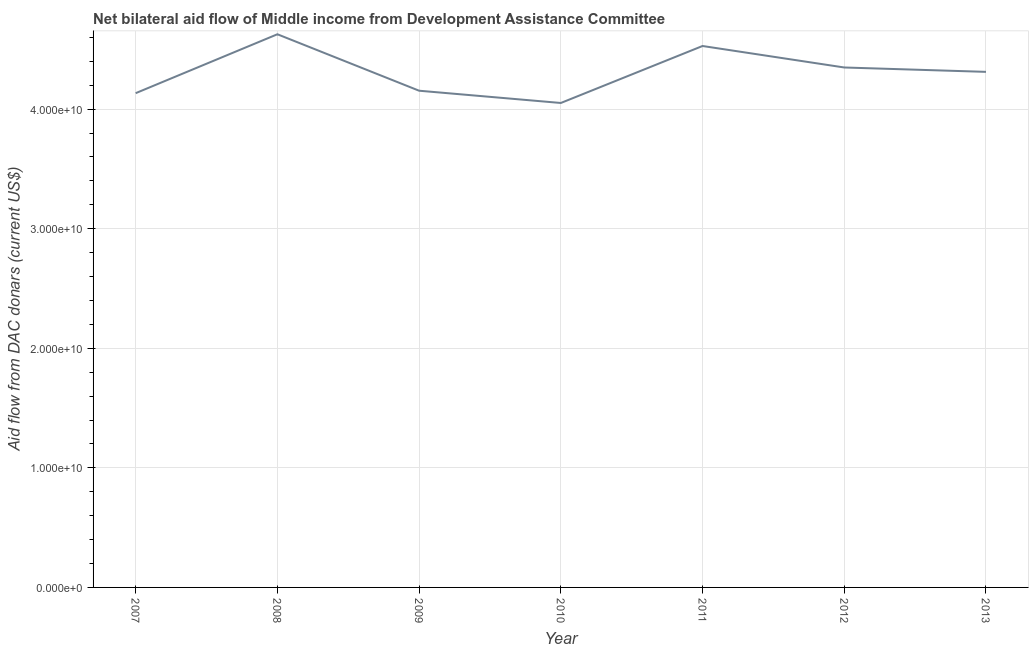What is the net bilateral aid flows from dac donors in 2010?
Your answer should be very brief. 4.05e+1. Across all years, what is the maximum net bilateral aid flows from dac donors?
Make the answer very short. 4.63e+1. Across all years, what is the minimum net bilateral aid flows from dac donors?
Provide a short and direct response. 4.05e+1. In which year was the net bilateral aid flows from dac donors minimum?
Offer a very short reply. 2010. What is the sum of the net bilateral aid flows from dac donors?
Provide a short and direct response. 3.02e+11. What is the difference between the net bilateral aid flows from dac donors in 2007 and 2011?
Keep it short and to the point. -3.94e+09. What is the average net bilateral aid flows from dac donors per year?
Ensure brevity in your answer.  4.31e+1. What is the median net bilateral aid flows from dac donors?
Your answer should be compact. 4.31e+1. In how many years, is the net bilateral aid flows from dac donors greater than 26000000000 US$?
Your answer should be compact. 7. Do a majority of the years between 2013 and 2008 (inclusive) have net bilateral aid flows from dac donors greater than 40000000000 US$?
Give a very brief answer. Yes. What is the ratio of the net bilateral aid flows from dac donors in 2009 to that in 2013?
Provide a succinct answer. 0.96. Is the net bilateral aid flows from dac donors in 2007 less than that in 2009?
Provide a short and direct response. Yes. Is the difference between the net bilateral aid flows from dac donors in 2007 and 2012 greater than the difference between any two years?
Your response must be concise. No. What is the difference between the highest and the second highest net bilateral aid flows from dac donors?
Your answer should be very brief. 9.81e+08. Is the sum of the net bilateral aid flows from dac donors in 2009 and 2010 greater than the maximum net bilateral aid flows from dac donors across all years?
Your answer should be very brief. Yes. What is the difference between the highest and the lowest net bilateral aid flows from dac donors?
Offer a very short reply. 5.75e+09. In how many years, is the net bilateral aid flows from dac donors greater than the average net bilateral aid flows from dac donors taken over all years?
Make the answer very short. 4. Does the net bilateral aid flows from dac donors monotonically increase over the years?
Ensure brevity in your answer.  No. How many years are there in the graph?
Provide a short and direct response. 7. Are the values on the major ticks of Y-axis written in scientific E-notation?
Your answer should be compact. Yes. What is the title of the graph?
Provide a short and direct response. Net bilateral aid flow of Middle income from Development Assistance Committee. What is the label or title of the X-axis?
Provide a short and direct response. Year. What is the label or title of the Y-axis?
Give a very brief answer. Aid flow from DAC donars (current US$). What is the Aid flow from DAC donars (current US$) in 2007?
Your answer should be very brief. 4.13e+1. What is the Aid flow from DAC donars (current US$) of 2008?
Provide a succinct answer. 4.63e+1. What is the Aid flow from DAC donars (current US$) of 2009?
Offer a terse response. 4.15e+1. What is the Aid flow from DAC donars (current US$) of 2010?
Your answer should be very brief. 4.05e+1. What is the Aid flow from DAC donars (current US$) of 2011?
Provide a short and direct response. 4.53e+1. What is the Aid flow from DAC donars (current US$) of 2012?
Keep it short and to the point. 4.35e+1. What is the Aid flow from DAC donars (current US$) of 2013?
Offer a terse response. 4.31e+1. What is the difference between the Aid flow from DAC donars (current US$) in 2007 and 2008?
Keep it short and to the point. -4.93e+09. What is the difference between the Aid flow from DAC donars (current US$) in 2007 and 2009?
Offer a very short reply. -2.05e+08. What is the difference between the Aid flow from DAC donars (current US$) in 2007 and 2010?
Ensure brevity in your answer.  8.20e+08. What is the difference between the Aid flow from DAC donars (current US$) in 2007 and 2011?
Your answer should be compact. -3.94e+09. What is the difference between the Aid flow from DAC donars (current US$) in 2007 and 2012?
Offer a terse response. -2.15e+09. What is the difference between the Aid flow from DAC donars (current US$) in 2007 and 2013?
Offer a terse response. -1.78e+09. What is the difference between the Aid flow from DAC donars (current US$) in 2008 and 2009?
Your response must be concise. 4.72e+09. What is the difference between the Aid flow from DAC donars (current US$) in 2008 and 2010?
Your answer should be compact. 5.75e+09. What is the difference between the Aid flow from DAC donars (current US$) in 2008 and 2011?
Offer a very short reply. 9.81e+08. What is the difference between the Aid flow from DAC donars (current US$) in 2008 and 2012?
Your answer should be compact. 2.78e+09. What is the difference between the Aid flow from DAC donars (current US$) in 2008 and 2013?
Make the answer very short. 3.14e+09. What is the difference between the Aid flow from DAC donars (current US$) in 2009 and 2010?
Provide a short and direct response. 1.03e+09. What is the difference between the Aid flow from DAC donars (current US$) in 2009 and 2011?
Your answer should be very brief. -3.74e+09. What is the difference between the Aid flow from DAC donars (current US$) in 2009 and 2012?
Your answer should be very brief. -1.94e+09. What is the difference between the Aid flow from DAC donars (current US$) in 2009 and 2013?
Your answer should be compact. -1.58e+09. What is the difference between the Aid flow from DAC donars (current US$) in 2010 and 2011?
Your answer should be very brief. -4.76e+09. What is the difference between the Aid flow from DAC donars (current US$) in 2010 and 2012?
Your response must be concise. -2.97e+09. What is the difference between the Aid flow from DAC donars (current US$) in 2010 and 2013?
Your response must be concise. -2.60e+09. What is the difference between the Aid flow from DAC donars (current US$) in 2011 and 2012?
Your response must be concise. 1.80e+09. What is the difference between the Aid flow from DAC donars (current US$) in 2011 and 2013?
Offer a very short reply. 2.16e+09. What is the difference between the Aid flow from DAC donars (current US$) in 2012 and 2013?
Provide a short and direct response. 3.66e+08. What is the ratio of the Aid flow from DAC donars (current US$) in 2007 to that in 2008?
Provide a short and direct response. 0.89. What is the ratio of the Aid flow from DAC donars (current US$) in 2007 to that in 2009?
Your answer should be compact. 0.99. What is the ratio of the Aid flow from DAC donars (current US$) in 2007 to that in 2011?
Give a very brief answer. 0.91. What is the ratio of the Aid flow from DAC donars (current US$) in 2007 to that in 2012?
Your answer should be compact. 0.95. What is the ratio of the Aid flow from DAC donars (current US$) in 2007 to that in 2013?
Give a very brief answer. 0.96. What is the ratio of the Aid flow from DAC donars (current US$) in 2008 to that in 2009?
Keep it short and to the point. 1.11. What is the ratio of the Aid flow from DAC donars (current US$) in 2008 to that in 2010?
Make the answer very short. 1.14. What is the ratio of the Aid flow from DAC donars (current US$) in 2008 to that in 2011?
Offer a terse response. 1.02. What is the ratio of the Aid flow from DAC donars (current US$) in 2008 to that in 2012?
Provide a short and direct response. 1.06. What is the ratio of the Aid flow from DAC donars (current US$) in 2008 to that in 2013?
Provide a succinct answer. 1.07. What is the ratio of the Aid flow from DAC donars (current US$) in 2009 to that in 2011?
Provide a short and direct response. 0.92. What is the ratio of the Aid flow from DAC donars (current US$) in 2009 to that in 2012?
Offer a very short reply. 0.95. What is the ratio of the Aid flow from DAC donars (current US$) in 2009 to that in 2013?
Provide a short and direct response. 0.96. What is the ratio of the Aid flow from DAC donars (current US$) in 2010 to that in 2011?
Your response must be concise. 0.9. What is the ratio of the Aid flow from DAC donars (current US$) in 2010 to that in 2012?
Provide a succinct answer. 0.93. What is the ratio of the Aid flow from DAC donars (current US$) in 2010 to that in 2013?
Offer a very short reply. 0.94. What is the ratio of the Aid flow from DAC donars (current US$) in 2011 to that in 2012?
Offer a terse response. 1.04. What is the ratio of the Aid flow from DAC donars (current US$) in 2011 to that in 2013?
Your answer should be very brief. 1.05. What is the ratio of the Aid flow from DAC donars (current US$) in 2012 to that in 2013?
Offer a terse response. 1.01. 